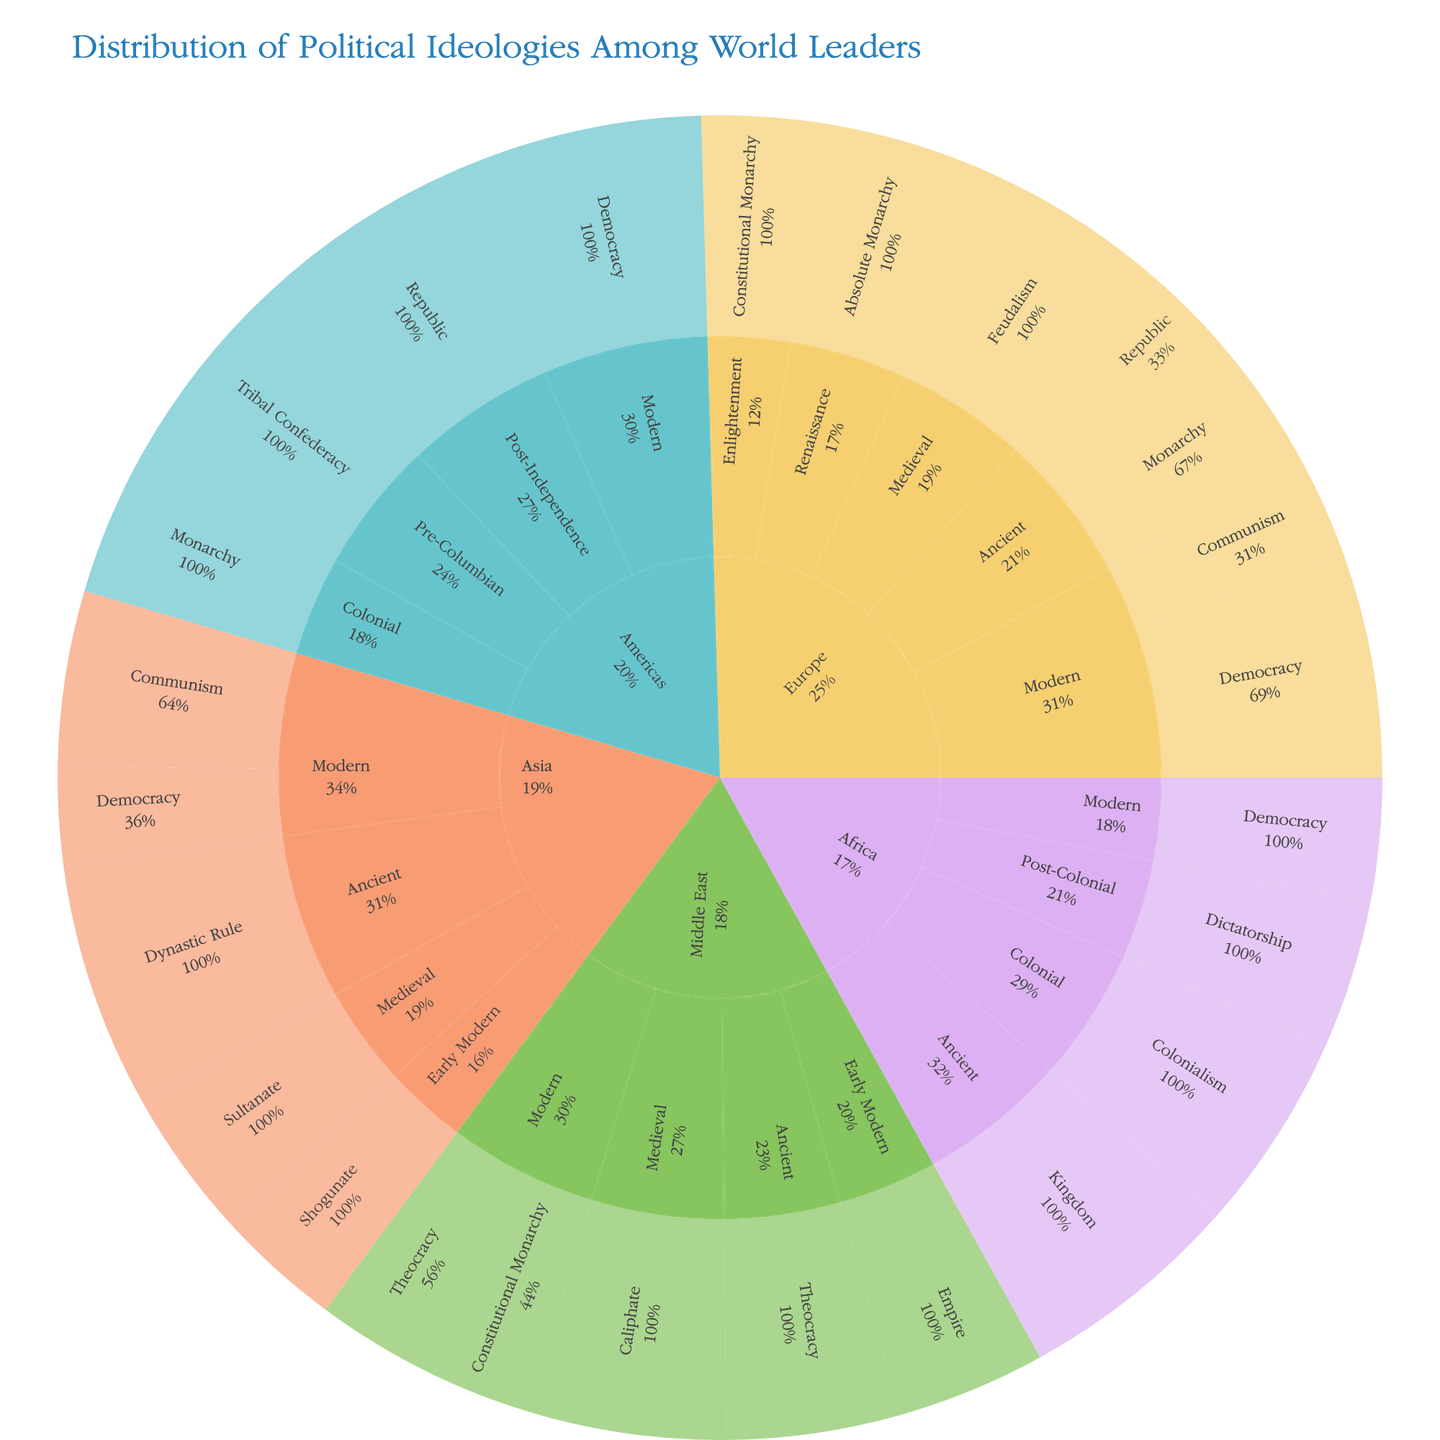How many different regions are analyzed in the plot? The plot shows segments labeled with different regions. By counting these labels, we can determine the number of regions analyzed.
Answer: 5 Which era in Europe has the highest value for political ideologies? By examining the segments under the 'Europe' region, we observe the value for each era. The 'Modern' era has the highest value.
Answer: Modern What is the combined value of Democracy across all regions? To get the combined value of Democracy, we sum the Democracy values from Europe (45), Asia (20), Americas (50), and Africa (25).
Answer: 140 Compare the value of Communism in Europe and Asia. Which one is higher, and by how much? The value of Communism in Europe is 20, while in Asia it is 35. To find which is higher and the difference, we compare both values.
Answer: Asia by 15 What percentage of Ancient ideologies in Asia is Dynastic Rule? Dynastic Rule is the only ideology under the Ancient era in Asia with a value of 50. Since it’s the only one, it constitutes 100% of Ancient ideologies in Asia.
Answer: 100% Which region-ideology combination under the Medieval era has the highest value? By examining the segments under the 'Medieval' era, we compare values: Europe (Feudalism, 40), Asia (Sultanate, 30), Middle East (Caliphate, 40). Europe and Middle East both have ideologies valued at 40.
Answer: Europe and Middle East What is the most common form of governance in the Americas' Pre-Columbian era? By looking at the plot’s segments for Americas under the Pre-Columbian era, we see that Tribal Confederacy is the identified form of governance.
Answer: Tribal Confederacy Identify the ideology in the Middle East that has the second highest value in any era. In the Middle East region, we see different ideologies and their values. The highest value is Caliphate (40, Medieval) and the second highest is Theocracy (35, Ancient).
Answer: Theocracy 